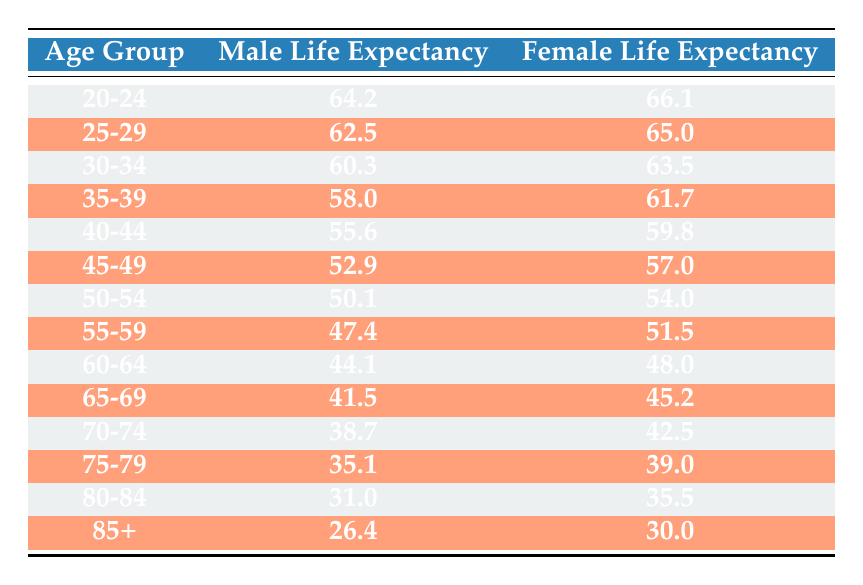What is the life expectancy of male employees aged 30-34? According to the table, for the age group 30-34, the life expectancy for male employees is listed as 60.3 years.
Answer: 60.3 What is the life expectancy of female employees in the age group 45-49? The table indicates that female employees aged 45-49 have a life expectancy of 57.0 years.
Answer: 57.0 Which age group has the highest life expectancy for females? By comparing the female life expectancy across age groups in the table, the age group 20-24 shows the highest life expectancy at 66.1 years.
Answer: 20-24 Is the life expectancy of males in the age group 70-74 higher than that of females in the age group 60-64? For the male life expectancy in the age group 70-74 is 38.7 years, while for females in the age group 60-64 it is 48.0 years; thus, 38.7 is not greater than 48.0, making the statement false.
Answer: No What is the average life expectancy of female employees in the age groups 55-59 and 60-64? The life expectancy for females aged 55-59 is 51.5 years, and for 60-64 it is 48.0 years. Adding these gives 51.5 + 48.0 = 99.5. Dividing by 2 provides the average, which is 99.5 / 2 = 49.75 years.
Answer: 49.75 What is the difference in life expectancy between males and females in the age group 80-84? The life expectancy for males aged 80-84 is 31.0 years, and for females, it is 35.5 years. The difference is 35.5 - 31.0 = 4.5 years.
Answer: 4.5 Do males have a consistently lower life expectancy than females across all age groups in the table? A review of the table reveals that males indeed have lower life expectancy values compared to females in each age group, confirming the statement as true.
Answer: Yes Which age group has the lowest life expectancy for male employees? The data shows that the age group 85+ has the lowest life expectancy for males at 26.4 years.
Answer: 85+ What is the sum of life expectancy values for males across the age groups 65-69 and 70-74? The life expectancy for males in the age group 65-69 is 41.5 years and for 70-74 it is 38.7 years. The sum is 41.5 + 38.7 = 80.2 years.
Answer: 80.2 